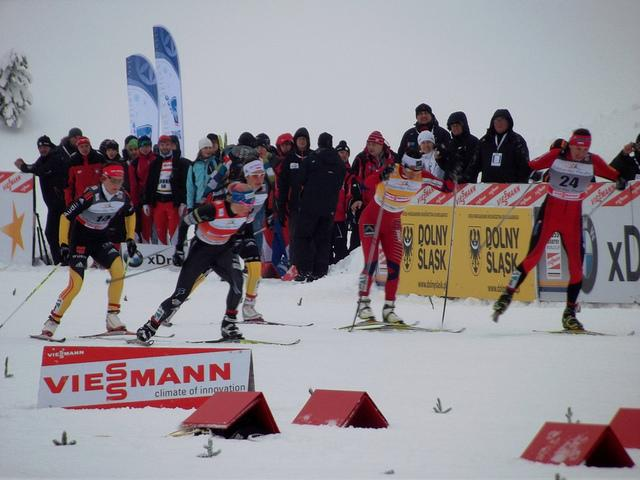What country does the sponsor closest to the camera have it's headquarters located? germany 